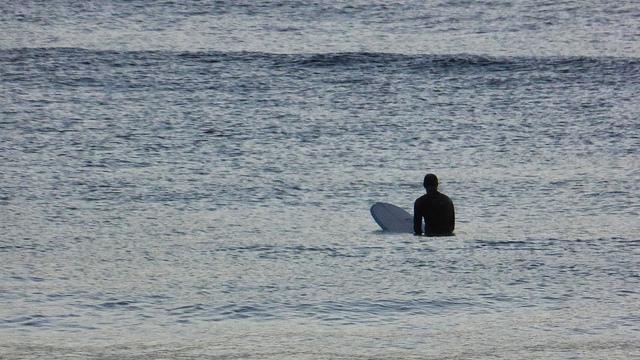How many people are in the water?
Give a very brief answer. 1. 